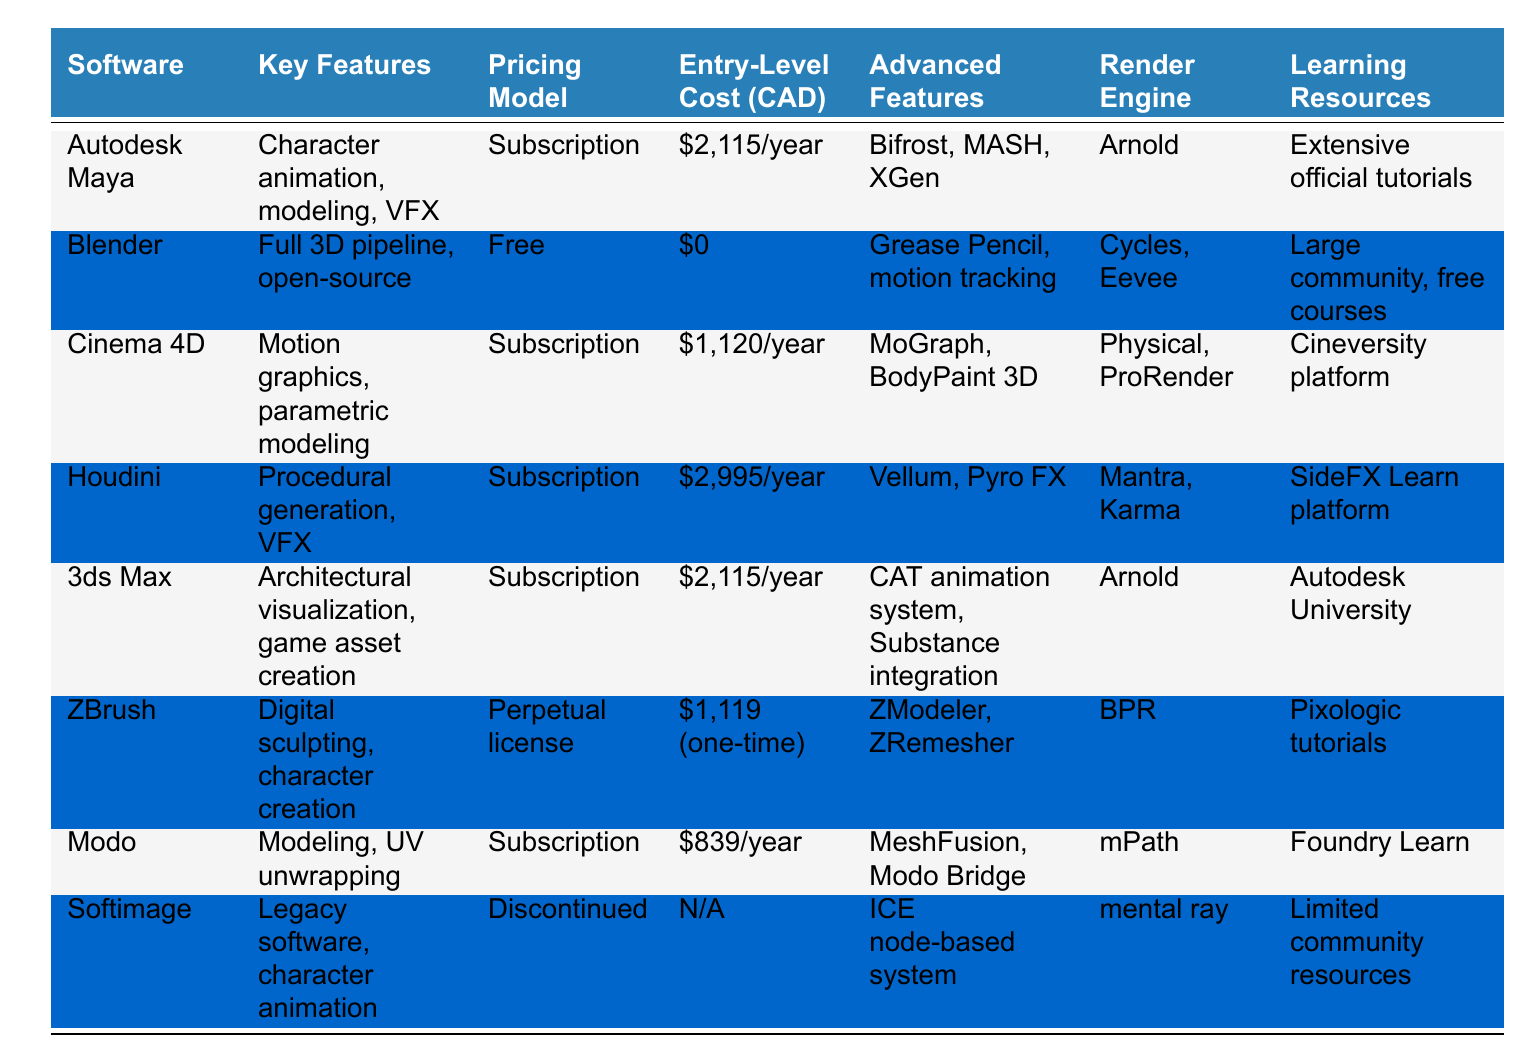What is the entry-level cost of Blender? The entry-level cost is listed under the "Entry-Level Cost (CAD)" column for Blender, which shows $0 for its pricing model.
Answer: $0 Which software has the highest entry-level cost? By comparing all the listed entry-level costs, Houdini has the highest cost at $2,995/year.
Answer: $2,995/year Is Softimage still available for purchase? The table indicates that Softimage is discontinued, hence it is not available for purchase.
Answer: No What features are unique to ZBrush? ZBrush is noted for its digital sculpting and character creation features, alongside advanced tools like ZModeler and ZRemesher.
Answer: Digital sculpting, character creation How many software have a subscription pricing model? Counting the software listed under the "Pricing Model" column shows five software that operate on a subscription basis: Autodesk Maya, Cinema 4D, Houdini, 3ds Max, and Modo.
Answer: 5 What is the cost difference between Cinema 4D and Modo? The entry-level cost of Cinema 4D is $1,120/year, while Modo is $839/year. The difference is $1,120 - $839 = $281.
Answer: $281 Which software has a render engine called Arnold? The render engines are listed under the "Render Engine" column, and both Autodesk Maya and 3ds Max use Arnold.
Answer: Autodesk Maya and 3ds Max How does the entry-level cost of Blender compare to ZBrush? Blender has an entry-level cost of $0, whereas ZBrush has a one-time cost of $1,119. The difference is significant, with ZBrush costing $1,119 more than Blender.
Answer: ZBrush costs $1,119 more Which software features motion tracking? Motion tracking is a feature of Blender, as specified in the "Key Features" column.
Answer: Blender If I want to learn through extensive official tutorials, which software should I choose? Autodesk Maya is highlighted as having extensive official tutorials in the "Learning Resources" section.
Answer: Autodesk Maya 